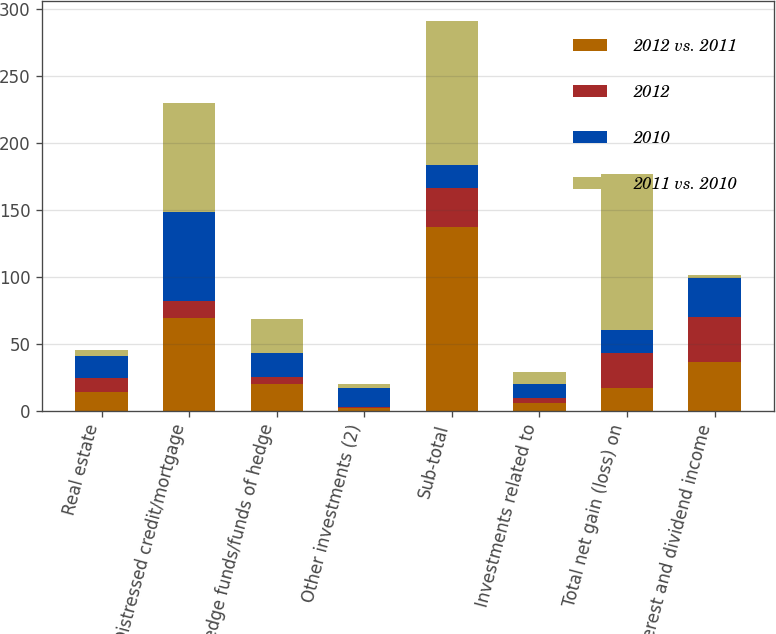Convert chart. <chart><loc_0><loc_0><loc_500><loc_500><stacked_bar_chart><ecel><fcel>Real estate<fcel>Distressed credit/mortgage<fcel>Hedge funds/funds of hedge<fcel>Other investments (2)<fcel>Sub-total<fcel>Investments related to<fcel>Total net gain (loss) on<fcel>Interest and dividend income<nl><fcel>2012 vs. 2011<fcel>14<fcel>69<fcel>20<fcel>2<fcel>137<fcel>6<fcel>17<fcel>36<nl><fcel>2012<fcel>10<fcel>13<fcel>5<fcel>1<fcel>29<fcel>3<fcel>26<fcel>34<nl><fcel>2010<fcel>17<fcel>66<fcel>18<fcel>14<fcel>17<fcel>11<fcel>17<fcel>29<nl><fcel>2011 vs. 2010<fcel>4<fcel>82<fcel>25<fcel>3<fcel>108<fcel>9<fcel>117<fcel>2<nl></chart> 